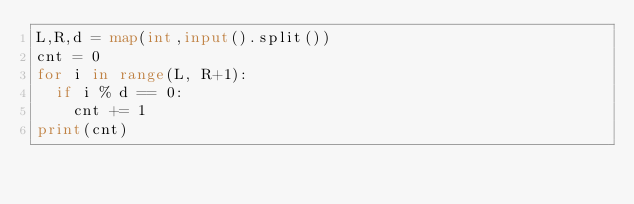Convert code to text. <code><loc_0><loc_0><loc_500><loc_500><_Python_>L,R,d = map(int,input().split())
cnt = 0
for i in range(L, R+1):
  if i % d == 0:
    cnt += 1
print(cnt)</code> 